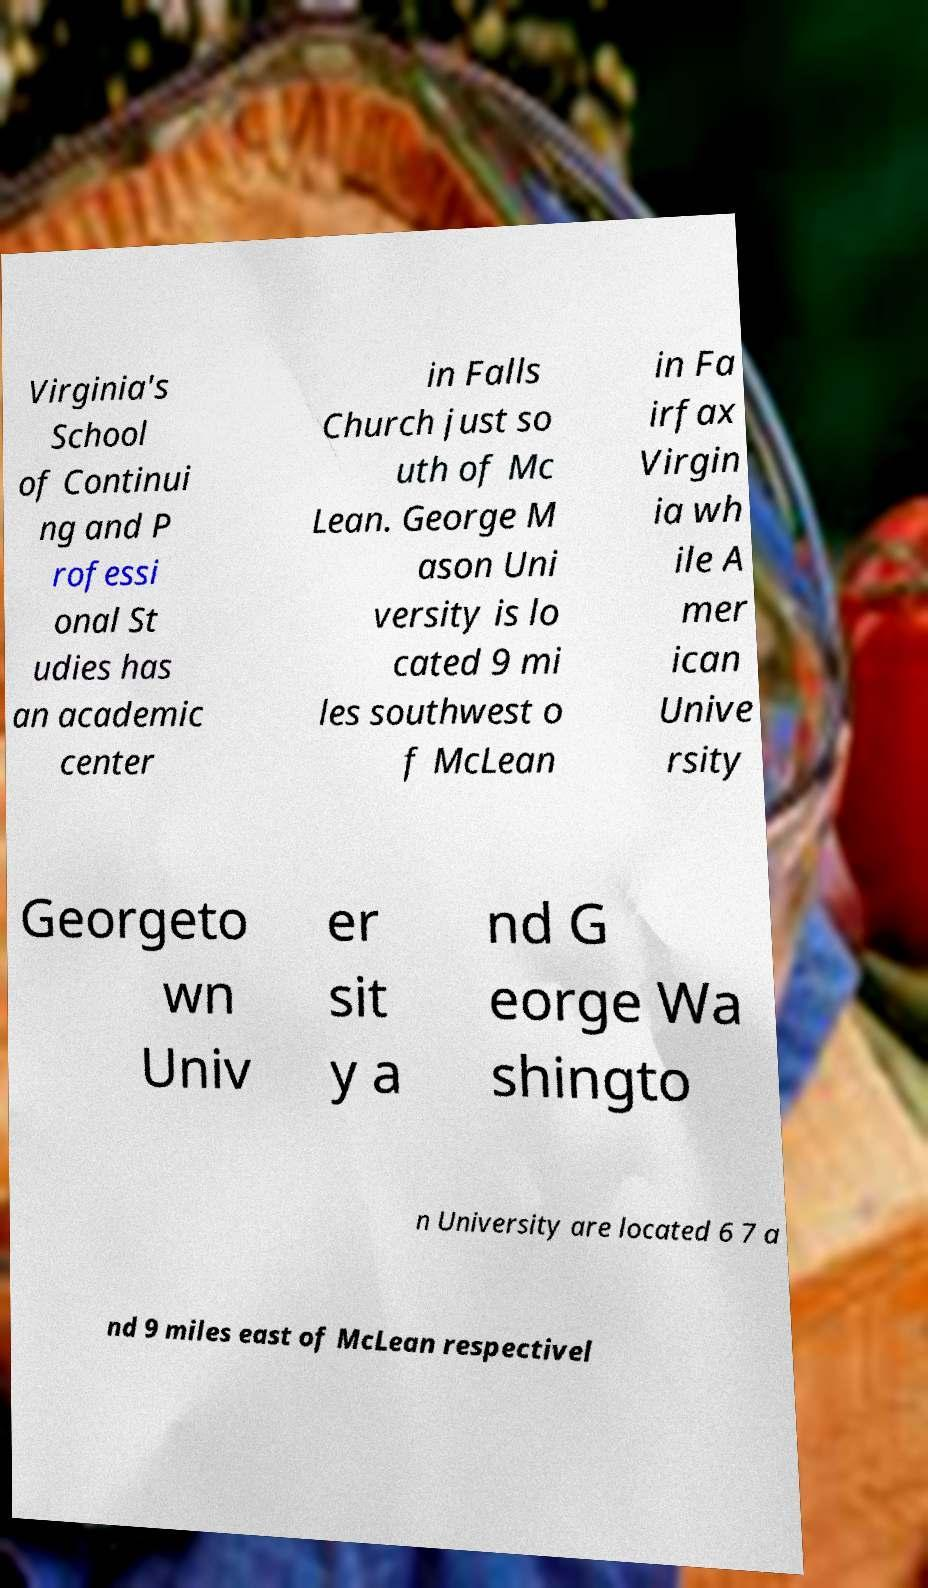There's text embedded in this image that I need extracted. Can you transcribe it verbatim? Virginia's School of Continui ng and P rofessi onal St udies has an academic center in Falls Church just so uth of Mc Lean. George M ason Uni versity is lo cated 9 mi les southwest o f McLean in Fa irfax Virgin ia wh ile A mer ican Unive rsity Georgeto wn Univ er sit y a nd G eorge Wa shingto n University are located 6 7 a nd 9 miles east of McLean respectivel 